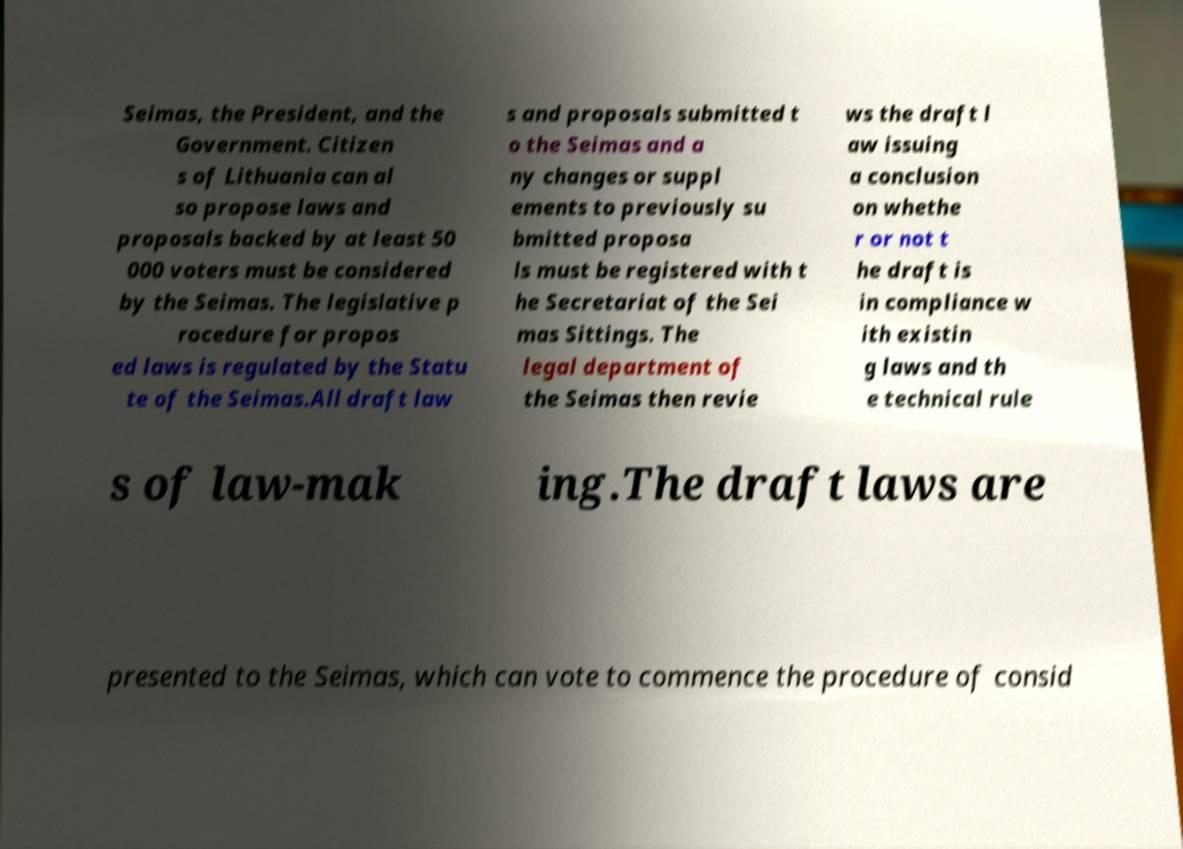Can you read and provide the text displayed in the image?This photo seems to have some interesting text. Can you extract and type it out for me? Seimas, the President, and the Government. Citizen s of Lithuania can al so propose laws and proposals backed by at least 50 000 voters must be considered by the Seimas. The legislative p rocedure for propos ed laws is regulated by the Statu te of the Seimas.All draft law s and proposals submitted t o the Seimas and a ny changes or suppl ements to previously su bmitted proposa ls must be registered with t he Secretariat of the Sei mas Sittings. The legal department of the Seimas then revie ws the draft l aw issuing a conclusion on whethe r or not t he draft is in compliance w ith existin g laws and th e technical rule s of law-mak ing.The draft laws are presented to the Seimas, which can vote to commence the procedure of consid 